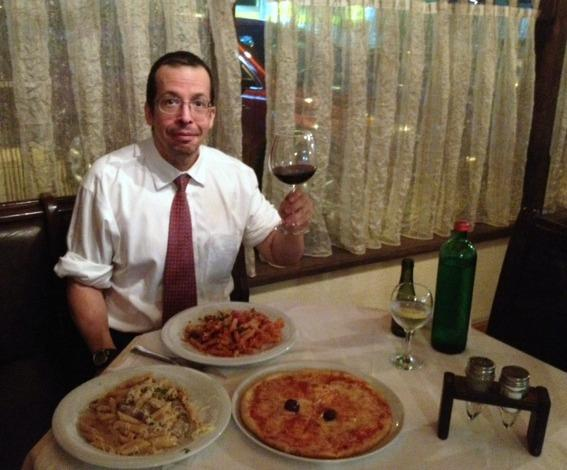Who does the person most look like? Please explain your reasoning. rick moranis. The person looks like moranis. 